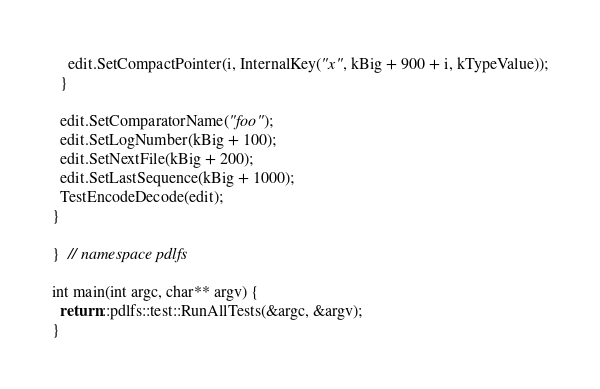<code> <loc_0><loc_0><loc_500><loc_500><_C++_>    edit.SetCompactPointer(i, InternalKey("x", kBig + 900 + i, kTypeValue));
  }

  edit.SetComparatorName("foo");
  edit.SetLogNumber(kBig + 100);
  edit.SetNextFile(kBig + 200);
  edit.SetLastSequence(kBig + 1000);
  TestEncodeDecode(edit);
}

}  // namespace pdlfs

int main(int argc, char** argv) {
  return ::pdlfs::test::RunAllTests(&argc, &argv);
}
</code> 